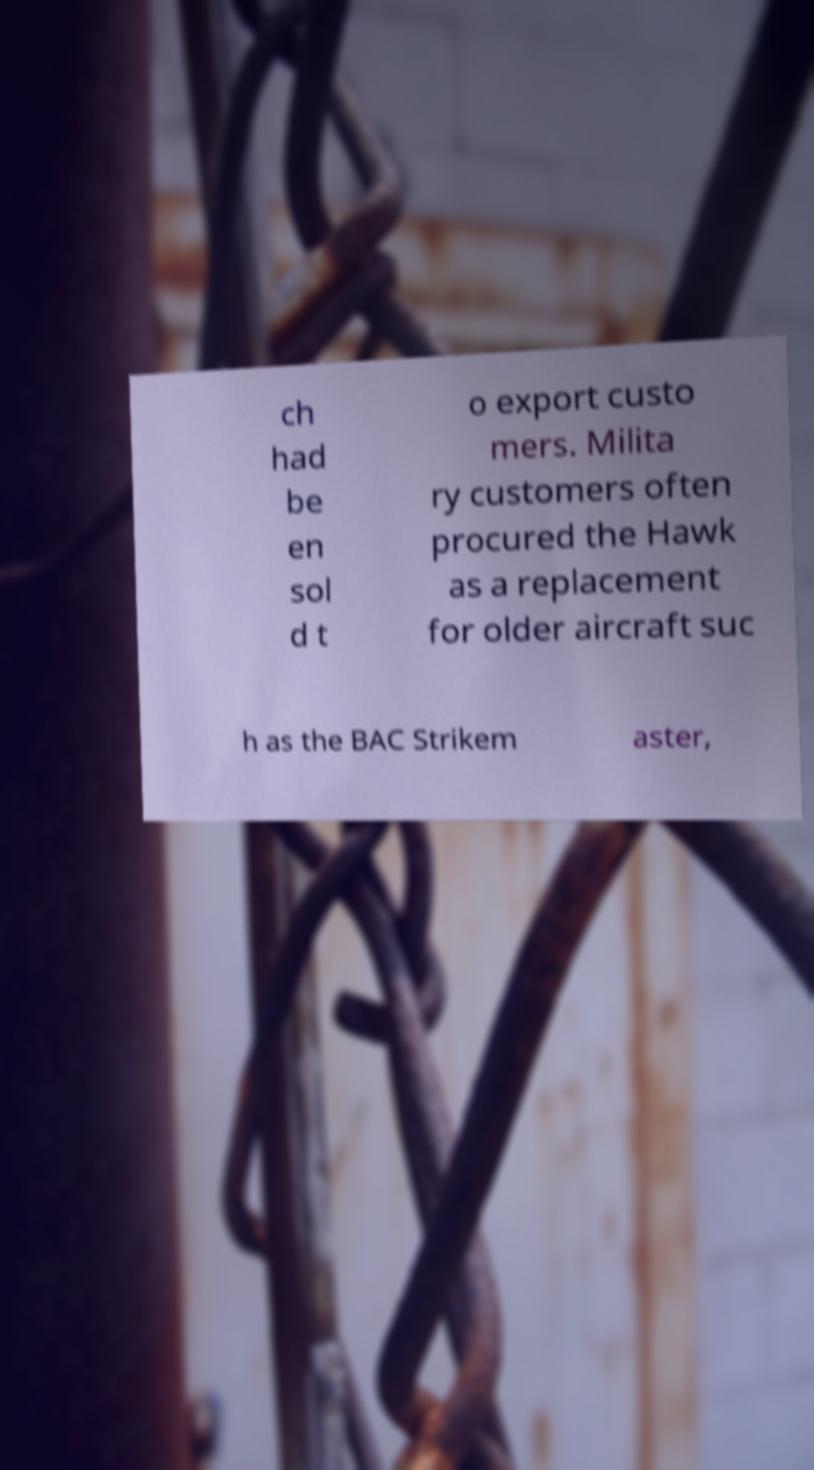Can you read and provide the text displayed in the image?This photo seems to have some interesting text. Can you extract and type it out for me? ch had be en sol d t o export custo mers. Milita ry customers often procured the Hawk as a replacement for older aircraft suc h as the BAC Strikem aster, 